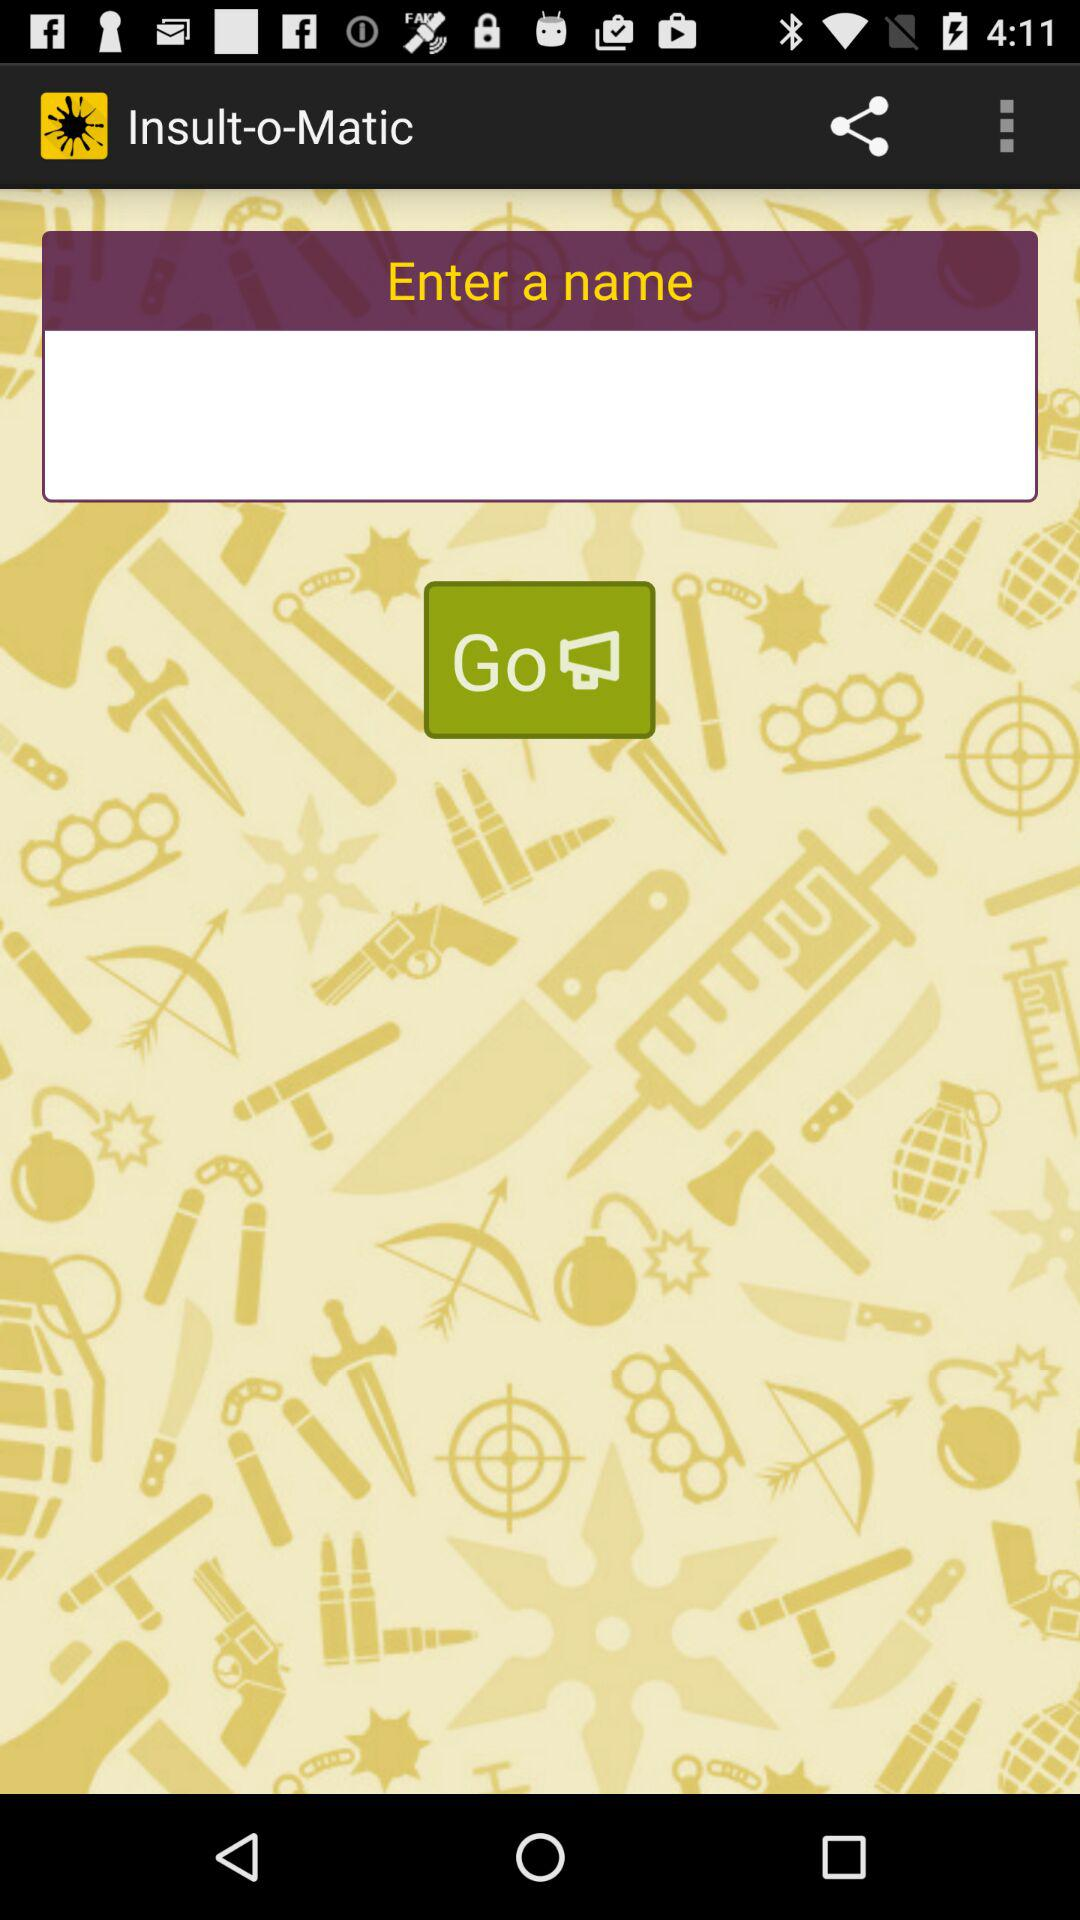What is the application Name? The application name is "Insult-o-Matic". 